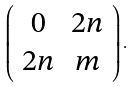<formula> <loc_0><loc_0><loc_500><loc_500>\left ( \begin{array} { c c } 0 & 2 n \\ 2 n & m \end{array} \right ) .</formula> 